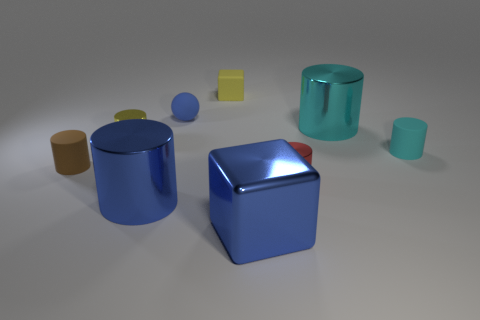Is the material of the large blue cylinder the same as the block that is in front of the small cyan matte object?
Your answer should be compact. Yes. The small sphere is what color?
Offer a very short reply. Blue. The cyan thing that is the same material as the tiny red thing is what size?
Provide a short and direct response. Large. There is a large shiny cylinder in front of the matte cylinder that is to the right of the large cyan metal thing; how many small metal cylinders are behind it?
Your answer should be compact. 2. Do the tiny rubber block and the small shiny cylinder to the left of the blue metal block have the same color?
Your response must be concise. Yes. What is the shape of the shiny object that is the same color as the shiny cube?
Make the answer very short. Cylinder. What is the material of the cyan thing in front of the cyan cylinder that is behind the tiny metal thing left of the small yellow rubber object?
Give a very brief answer. Rubber. Is the shape of the tiny yellow object behind the small blue thing the same as  the brown matte object?
Offer a terse response. No. What is the big blue object in front of the blue shiny cylinder made of?
Make the answer very short. Metal. What number of metal things are either blue spheres or big blue objects?
Your answer should be very brief. 2. 